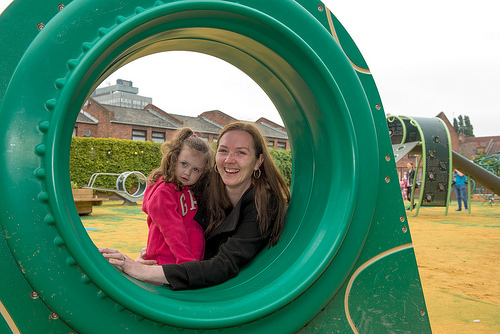<image>
Is the roof in front of the girl? No. The roof is not in front of the girl. The spatial positioning shows a different relationship between these objects. 